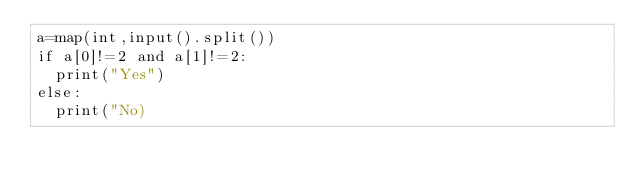Convert code to text. <code><loc_0><loc_0><loc_500><loc_500><_Python_>a=map(int,input().split())
if a[0]!=2 and a[1]!=2:
  print("Yes")
else:
  print("No)</code> 